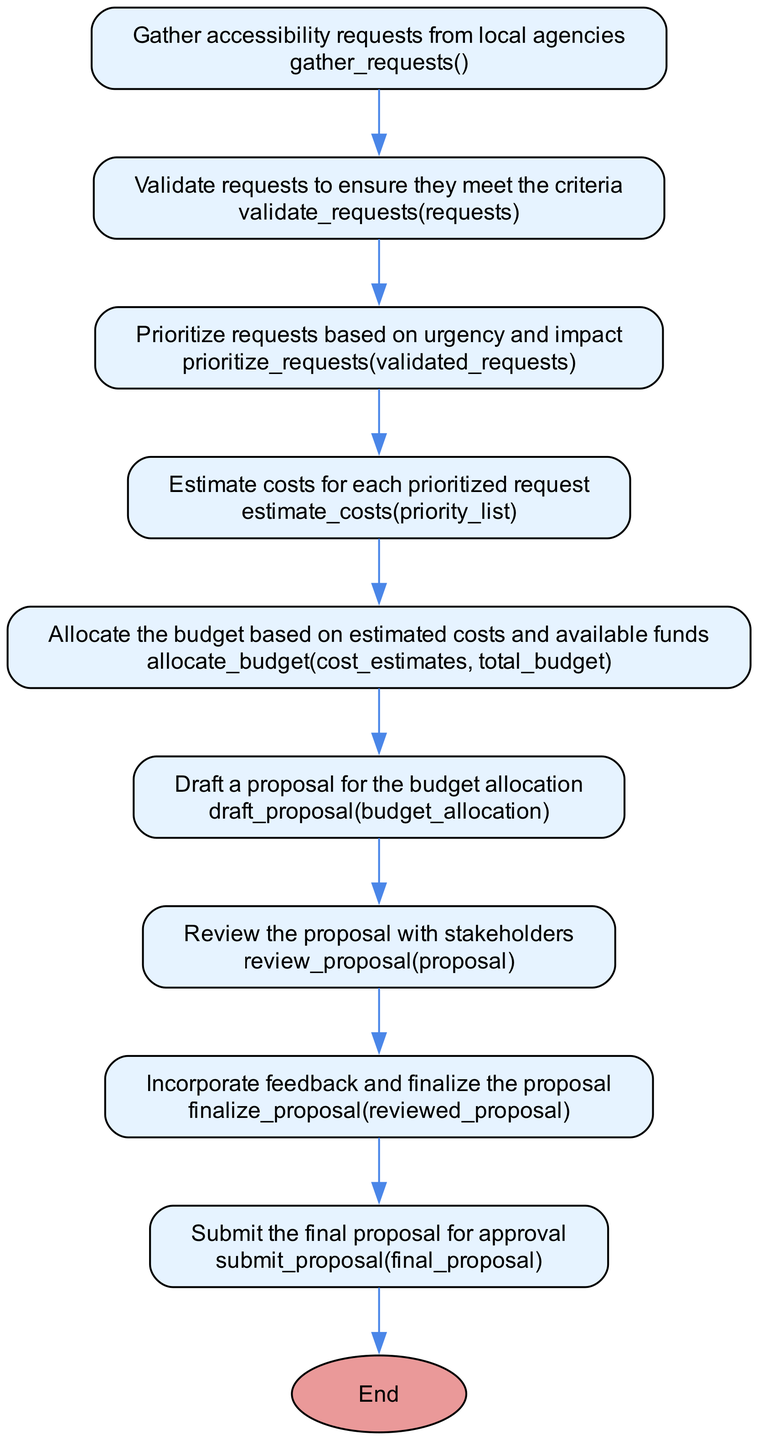What is the first step in the process? The first step in the process, identified by the 'start' node, is to 'Gather accessibility requests from local agencies'. This is indicated at the top of the flowchart.
Answer: Gather accessibility requests from local agencies How many nodes are in the process? To find the number of nodes, we count all the unique steps listed in the diagram, including the start and end nodes. There are 10 distinct nodes in total.
Answer: 10 What action is taken after validating requests? After the 'Validate requests' step, the next action taken is 'Prioritize requests based on urgency and impact'. This follows the flow from the validation process.
Answer: Prioritize requests based on urgency and impact What is the final action in allocating the budget? The last action in the process is to 'Submit the final proposal for approval', which comes just before the final 'End' node. This shows the completion of the budget allocation process.
Answer: Submit the final proposal for approval What is the relationship between estimating costs and allocating budget? The flow shows that after the 'Estimate costs for each prioritized request', the next step is to 'Allocate the budget based on estimated costs and available funds'. This indicates a direct link between estimating costs and the allocation of the budget, implying that cost estimates inform the allocation process.
Answer: Allocate the budget based on estimated costs and available funds How many steps include a validation in their description? Upon review of the steps, we find there are two instances of validation: 'Validate requests to ensure they meet the criteria' and 'Review the proposal with stakeholders'. This reflects the importance of validating both requests and proposals throughout the process.
Answer: 2 Which step comes immediately before drafting a proposal? The step that comes immediately before 'Draft a proposal for the budget allocation' is 'Allocate the budget based on estimated costs and available funds'. This direct flow indicates the sequence of actions leading up to the proposal drafting stage.
Answer: Allocate the budget based on estimated costs and available funds What action follows the review of the proposal? The action that follows reviewing the proposal with stakeholders is to 'Incorporate feedback and finalize the proposal'. This shows the iterative nature of the process, as it includes feedback loop mechanisms.
Answer: Incorporate feedback and finalize the proposal What shape is used for the start and end nodes? The start and end nodes are represented as ovals. This design choice typically indicates the beginning and conclusion of a process in flowcharts.
Answer: Oval 